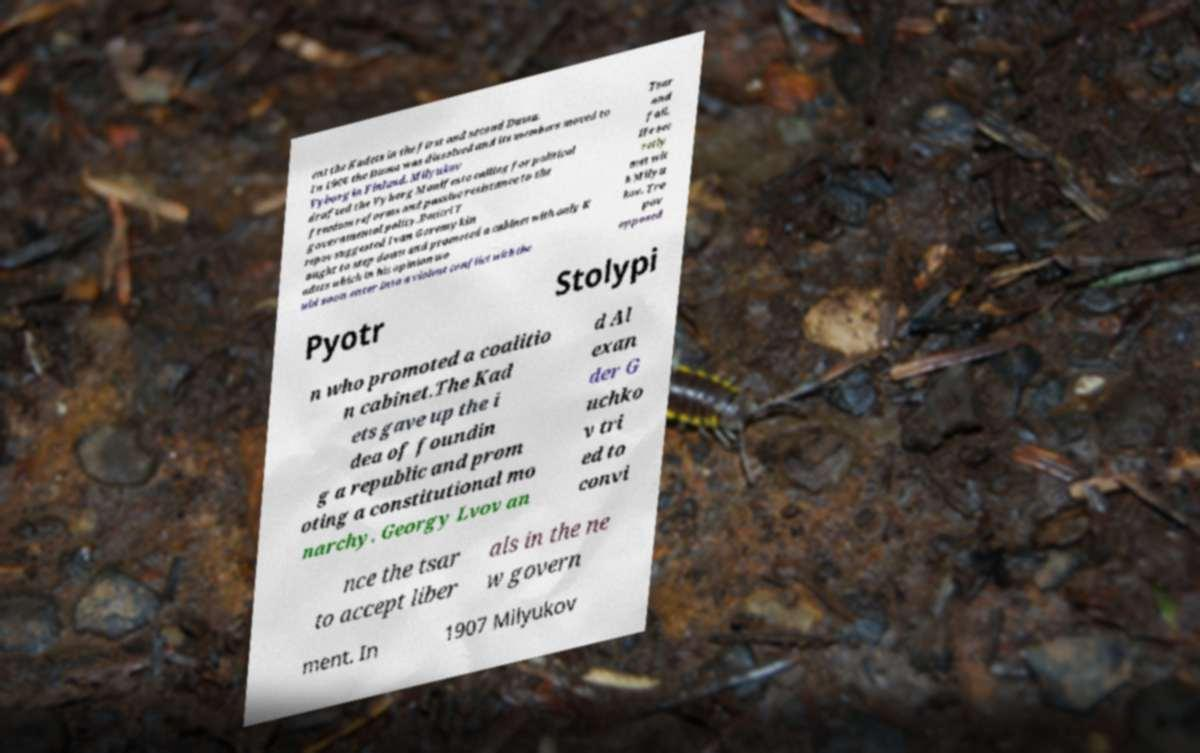Can you accurately transcribe the text from the provided image for me? ent the Kadets in the first and second Duma. In 1906 the Duma was dissolved and its members moved to Vyborg in Finland. Milyukov drafted the Vyborg Manifesto calling for political freedom reforms and passive resistance to the governmental policy.Dmitri T repov suggested Ivan Goremykin ought to step down and promoted a cabinet with only K adets which in his opinion wo uld soon enter into a violent conflict with the Tsar and fail. He sec retly met wit h Milyu kov. Tre pov opposed Pyotr Stolypi n who promoted a coalitio n cabinet.The Kad ets gave up the i dea of foundin g a republic and prom oting a constitutional mo narchy. Georgy Lvov an d Al exan der G uchko v tri ed to convi nce the tsar to accept liber als in the ne w govern ment. In 1907 Milyukov 